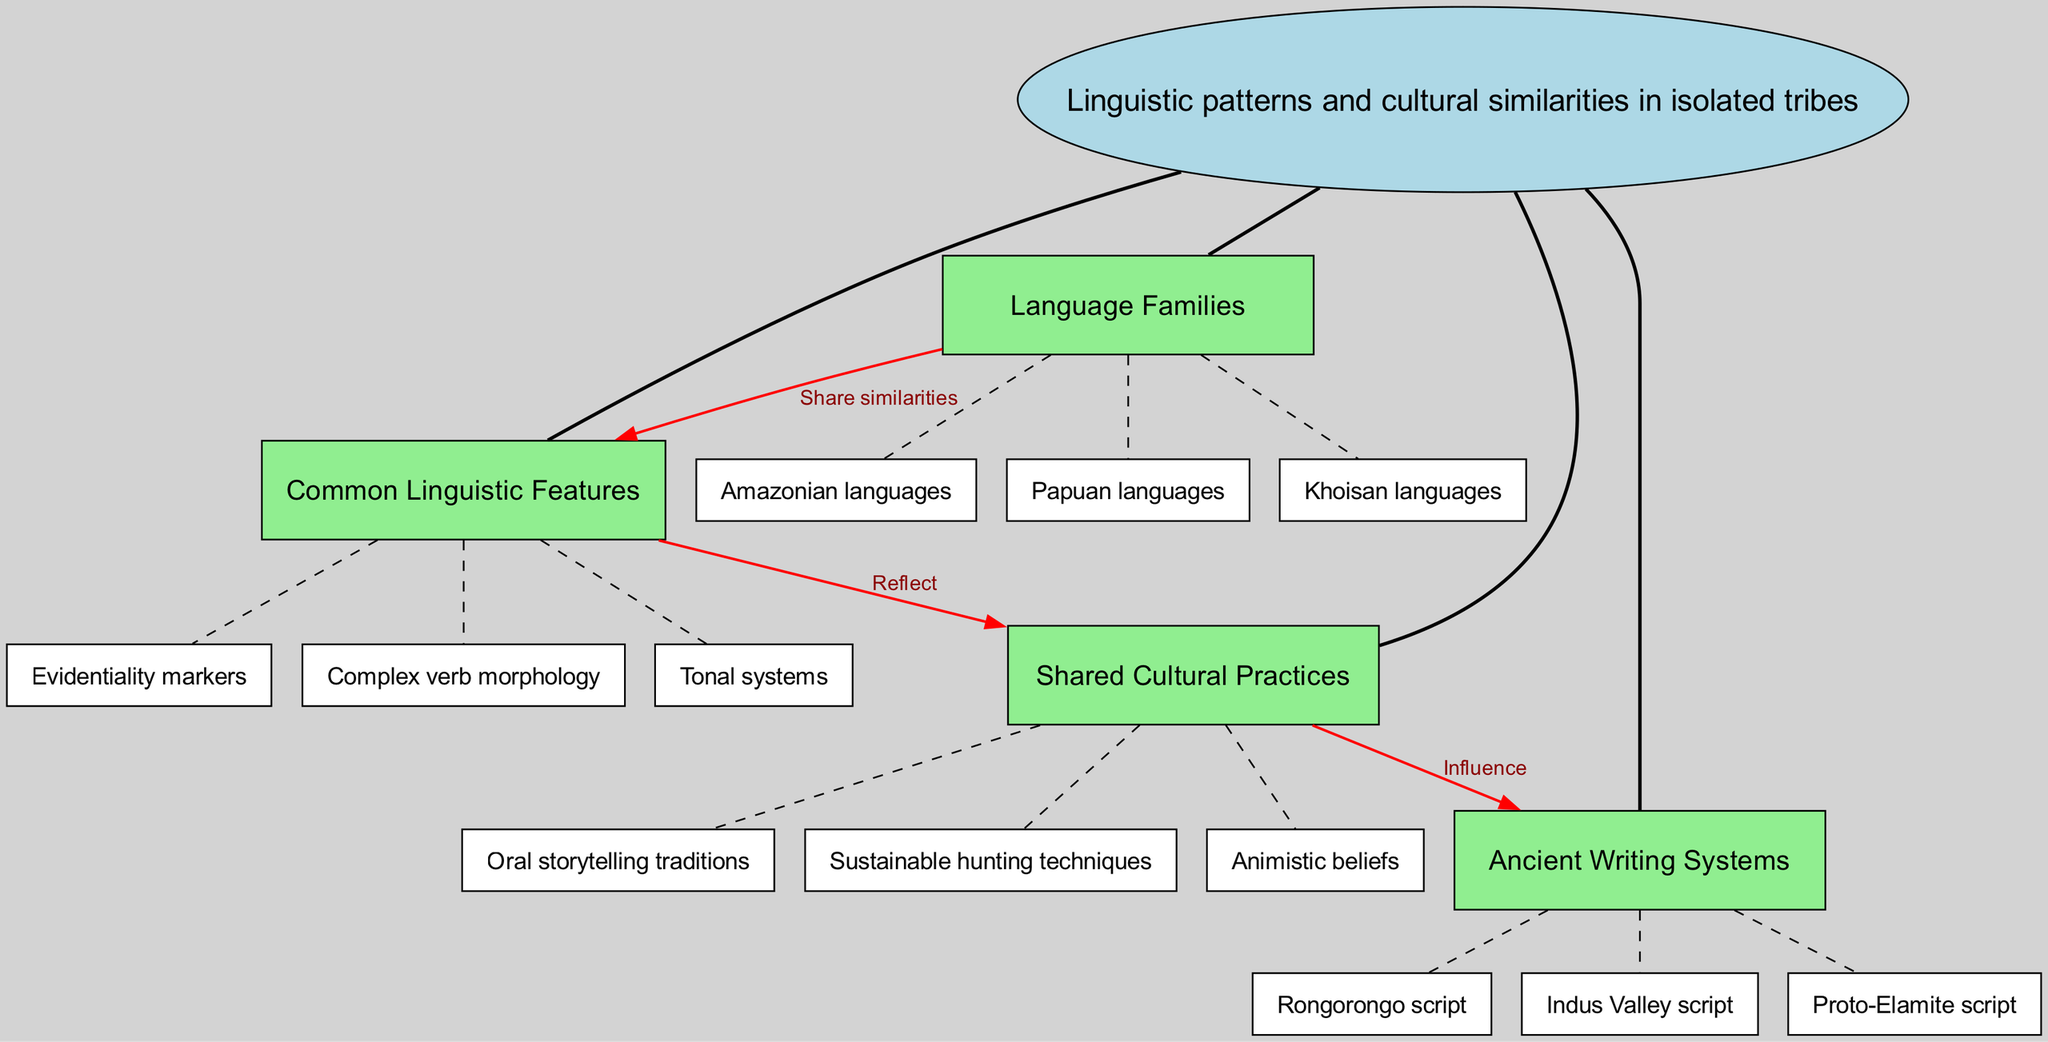What are the three language families listed? The subnodes under the "Language Families" branch are "Amazonian languages," "Papuan languages," and "Khoisan languages." Therefore, the three languages are those subnodes themselves.
Answer: Amazonian languages, Papuan languages, Khoisan languages How many main branches are there? The diagram features four main branches: "Language Families," "Shared Cultural Practices," "Common Linguistic Features," and "Ancient Writing Systems." Thus, the count is straightforwardly four.
Answer: 4 What is a shared cultural practice listed in the diagram? By checking the subnodes under the "Shared Cultural Practices" branch in the diagram, we can see "Animistic beliefs" is one of the examples provided.
Answer: Animistic beliefs Which two nodes are connected by the label "Reflect"? The "Reflect" label connects the "Common Linguistic Features" and "Shared Cultural Practices," indicating the relationship between these two concepts in the diagram.
Answer: Common Linguistic Features, Shared Cultural Practices What does the connection from "Language Families" to "Common Linguistic Features" indicate? The connection from "Language Families" to "Common Linguistic Features" is labeled as "Share similarities," signifying that these two aspects have a comparative relationship outlined in the diagram.
Answer: Share similarities How many subnodes are listed under "Common Linguistic Features"? The "Common Linguistic Features" branch contains three subnodes: "Tonal systems," "Evidentiality markers," and "Complex verb morphology." This gives us a total of three subnodes.
Answer: 3 Which ancient writing systems are mentioned? The subnodes under "Ancient Writing Systems" include "Rongorongo script," "Indus Valley script," and "Proto-Elamite script," thus identifying these specific writing systems featured in the concept map.
Answer: Rongorongo script, Indus Valley script, Proto-Elamite script What type of beliefs do the shared cultural practices include? The shared cultural practices categorize as "Animistic beliefs," which refers to a type of belief system that is mentioned under the specific node in the diagram.
Answer: Animistic beliefs How does "Shared Cultural Practices" influence "Ancient Writing Systems"? The relationship marked by "Influence" between "Shared Cultural Practices" and "Ancient Writing Systems" indicates that the cultural practices have an historical or contextual effect on the emergence or development of writing systems mentioned.
Answer: Influence 